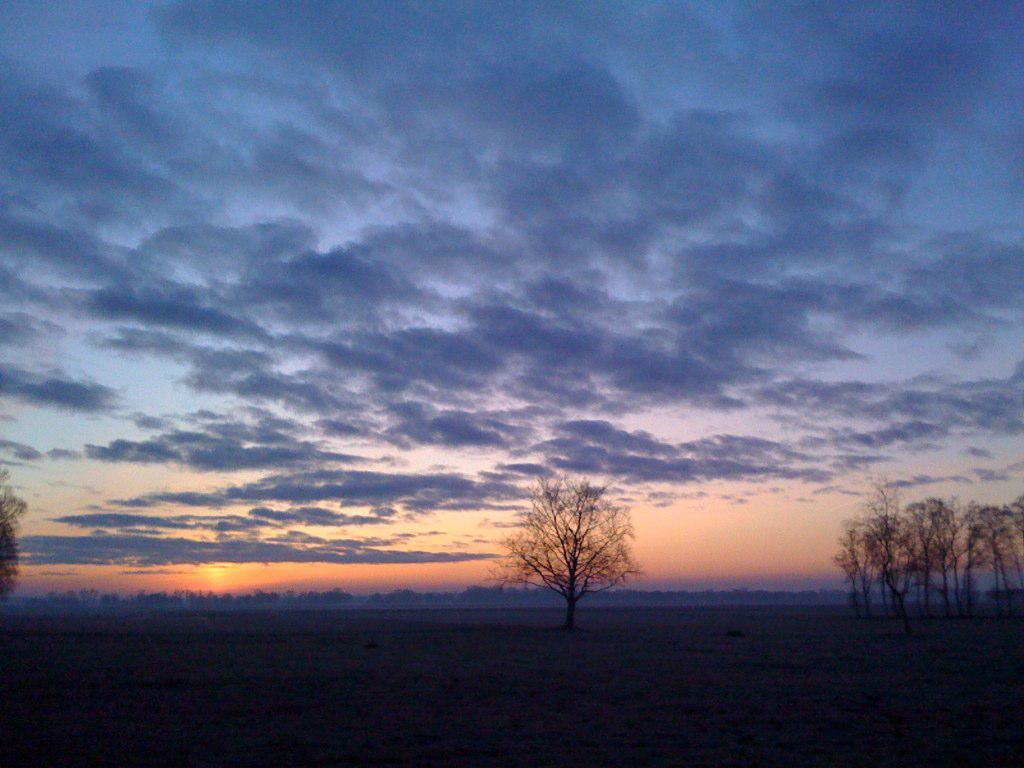How would you summarize this image in a sentence or two? In this image, we can see some trees, at the top there is a sky which is cloudy. 